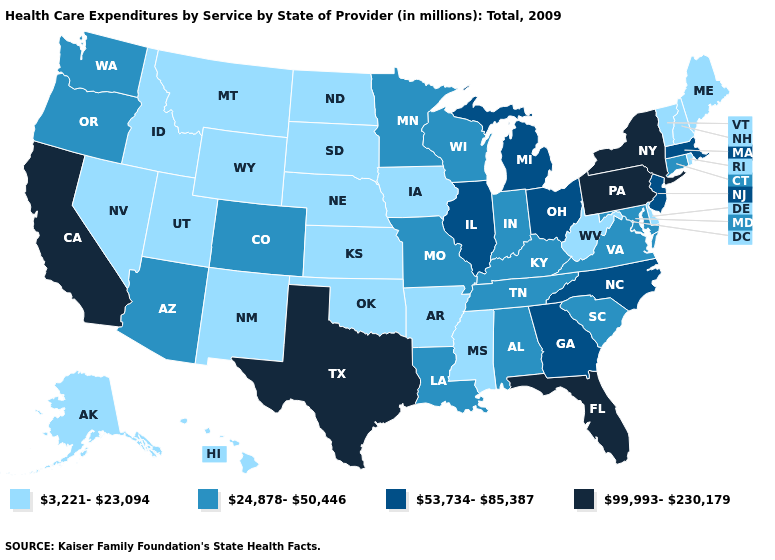What is the value of Oregon?
Be succinct. 24,878-50,446. Name the states that have a value in the range 53,734-85,387?
Concise answer only. Georgia, Illinois, Massachusetts, Michigan, New Jersey, North Carolina, Ohio. Name the states that have a value in the range 3,221-23,094?
Give a very brief answer. Alaska, Arkansas, Delaware, Hawaii, Idaho, Iowa, Kansas, Maine, Mississippi, Montana, Nebraska, Nevada, New Hampshire, New Mexico, North Dakota, Oklahoma, Rhode Island, South Dakota, Utah, Vermont, West Virginia, Wyoming. Name the states that have a value in the range 24,878-50,446?
Keep it brief. Alabama, Arizona, Colorado, Connecticut, Indiana, Kentucky, Louisiana, Maryland, Minnesota, Missouri, Oregon, South Carolina, Tennessee, Virginia, Washington, Wisconsin. What is the value of Illinois?
Concise answer only. 53,734-85,387. Among the states that border Utah , which have the lowest value?
Keep it brief. Idaho, Nevada, New Mexico, Wyoming. Name the states that have a value in the range 99,993-230,179?
Short answer required. California, Florida, New York, Pennsylvania, Texas. Name the states that have a value in the range 24,878-50,446?
Give a very brief answer. Alabama, Arizona, Colorado, Connecticut, Indiana, Kentucky, Louisiana, Maryland, Minnesota, Missouri, Oregon, South Carolina, Tennessee, Virginia, Washington, Wisconsin. What is the value of Alaska?
Keep it brief. 3,221-23,094. Does Idaho have the lowest value in the USA?
Concise answer only. Yes. What is the lowest value in states that border Idaho?
Give a very brief answer. 3,221-23,094. How many symbols are there in the legend?
Keep it brief. 4. What is the value of New Mexico?
Concise answer only. 3,221-23,094. What is the lowest value in the USA?
Quick response, please. 3,221-23,094. Does Texas have the highest value in the USA?
Be succinct. Yes. 